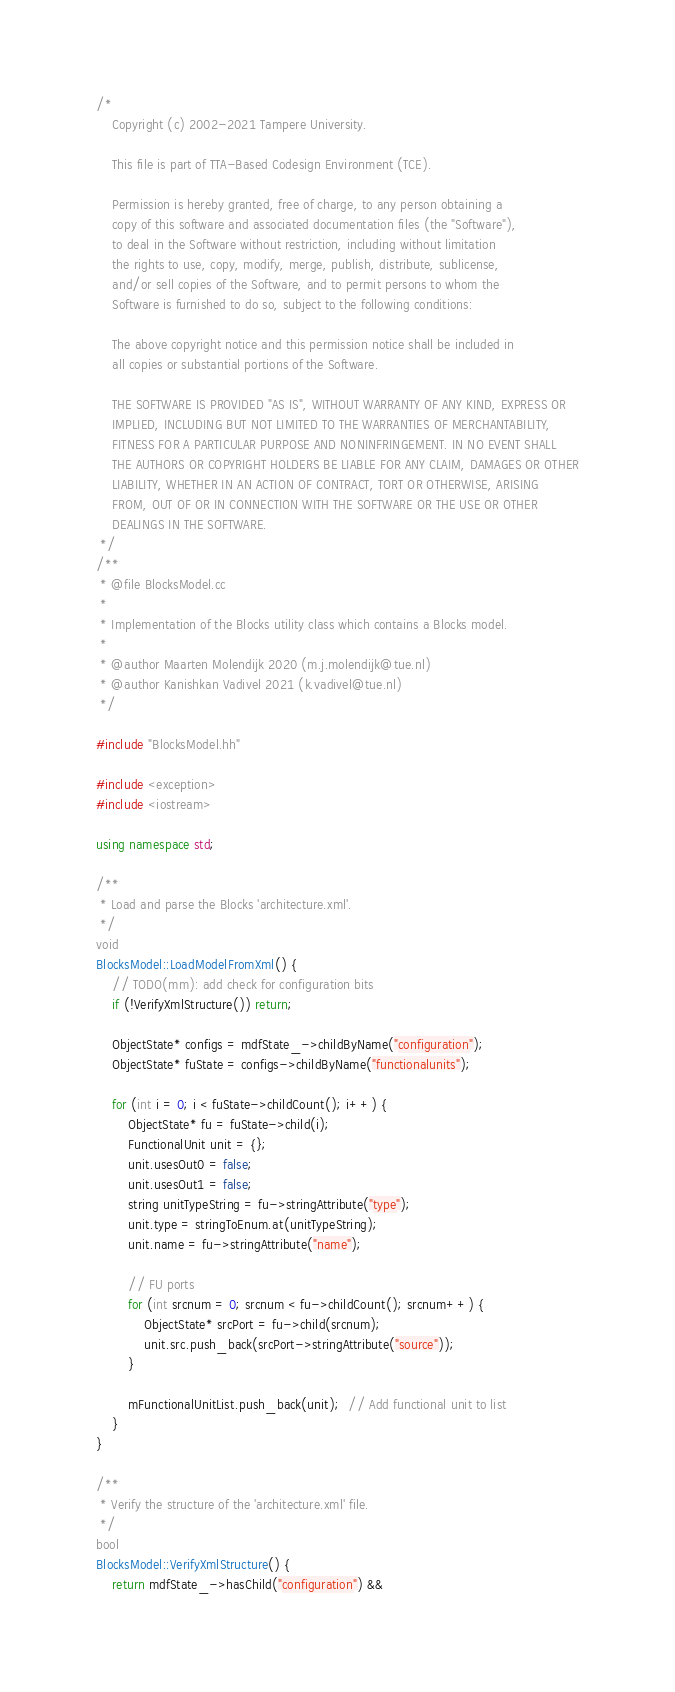<code> <loc_0><loc_0><loc_500><loc_500><_C++_>/*
    Copyright (c) 2002-2021 Tampere University.

    This file is part of TTA-Based Codesign Environment (TCE).

    Permission is hereby granted, free of charge, to any person obtaining a
    copy of this software and associated documentation files (the "Software"),
    to deal in the Software without restriction, including without limitation
    the rights to use, copy, modify, merge, publish, distribute, sublicense,
    and/or sell copies of the Software, and to permit persons to whom the
    Software is furnished to do so, subject to the following conditions:

    The above copyright notice and this permission notice shall be included in
    all copies or substantial portions of the Software.

    THE SOFTWARE IS PROVIDED "AS IS", WITHOUT WARRANTY OF ANY KIND, EXPRESS OR
    IMPLIED, INCLUDING BUT NOT LIMITED TO THE WARRANTIES OF MERCHANTABILITY,
    FITNESS FOR A PARTICULAR PURPOSE AND NONINFRINGEMENT. IN NO EVENT SHALL
    THE AUTHORS OR COPYRIGHT HOLDERS BE LIABLE FOR ANY CLAIM, DAMAGES OR OTHER
    LIABILITY, WHETHER IN AN ACTION OF CONTRACT, TORT OR OTHERWISE, ARISING
    FROM, OUT OF OR IN CONNECTION WITH THE SOFTWARE OR THE USE OR OTHER
    DEALINGS IN THE SOFTWARE.
 */
/**
 * @file BlocksModel.cc
 *
 * Implementation of the Blocks utility class which contains a Blocks model.
 *
 * @author Maarten Molendijk 2020 (m.j.molendijk@tue.nl)
 * @author Kanishkan Vadivel 2021 (k.vadivel@tue.nl)
 */

#include "BlocksModel.hh"

#include <exception>
#include <iostream>

using namespace std;

/**
 * Load and parse the Blocks 'architecture.xml'.
 */
void
BlocksModel::LoadModelFromXml() {
    // TODO(mm): add check for configuration bits
    if (!VerifyXmlStructure()) return;

    ObjectState* configs = mdfState_->childByName("configuration");
    ObjectState* fuState = configs->childByName("functionalunits");

    for (int i = 0; i < fuState->childCount(); i++) {
        ObjectState* fu = fuState->child(i);
        FunctionalUnit unit = {};
        unit.usesOut0 = false;
        unit.usesOut1 = false;
        string unitTypeString = fu->stringAttribute("type");
        unit.type = stringToEnum.at(unitTypeString);
        unit.name = fu->stringAttribute("name");

        // FU ports
        for (int srcnum = 0; srcnum < fu->childCount(); srcnum++) {
            ObjectState* srcPort = fu->child(srcnum);
            unit.src.push_back(srcPort->stringAttribute("source"));
        }

        mFunctionalUnitList.push_back(unit);  // Add functional unit to list
    }
}

/**
 * Verify the structure of the 'architecture.xml' file.
 */
bool
BlocksModel::VerifyXmlStructure() {
    return mdfState_->hasChild("configuration") &&</code> 